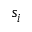<formula> <loc_0><loc_0><loc_500><loc_500>s _ { i }</formula> 